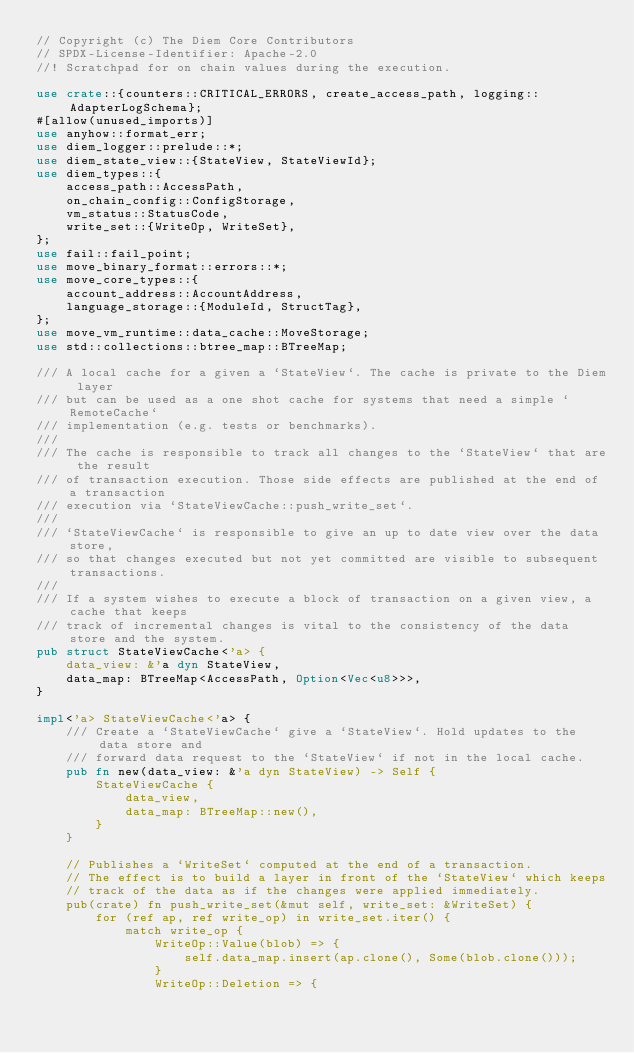<code> <loc_0><loc_0><loc_500><loc_500><_Rust_>// Copyright (c) The Diem Core Contributors
// SPDX-License-Identifier: Apache-2.0
//! Scratchpad for on chain values during the execution.

use crate::{counters::CRITICAL_ERRORS, create_access_path, logging::AdapterLogSchema};
#[allow(unused_imports)]
use anyhow::format_err;
use diem_logger::prelude::*;
use diem_state_view::{StateView, StateViewId};
use diem_types::{
    access_path::AccessPath,
    on_chain_config::ConfigStorage,
    vm_status::StatusCode,
    write_set::{WriteOp, WriteSet},
};
use fail::fail_point;
use move_binary_format::errors::*;
use move_core_types::{
    account_address::AccountAddress,
    language_storage::{ModuleId, StructTag},
};
use move_vm_runtime::data_cache::MoveStorage;
use std::collections::btree_map::BTreeMap;

/// A local cache for a given a `StateView`. The cache is private to the Diem layer
/// but can be used as a one shot cache for systems that need a simple `RemoteCache`
/// implementation (e.g. tests or benchmarks).
///
/// The cache is responsible to track all changes to the `StateView` that are the result
/// of transaction execution. Those side effects are published at the end of a transaction
/// execution via `StateViewCache::push_write_set`.
///
/// `StateViewCache` is responsible to give an up to date view over the data store,
/// so that changes executed but not yet committed are visible to subsequent transactions.
///
/// If a system wishes to execute a block of transaction on a given view, a cache that keeps
/// track of incremental changes is vital to the consistency of the data store and the system.
pub struct StateViewCache<'a> {
    data_view: &'a dyn StateView,
    data_map: BTreeMap<AccessPath, Option<Vec<u8>>>,
}

impl<'a> StateViewCache<'a> {
    /// Create a `StateViewCache` give a `StateView`. Hold updates to the data store and
    /// forward data request to the `StateView` if not in the local cache.
    pub fn new(data_view: &'a dyn StateView) -> Self {
        StateViewCache {
            data_view,
            data_map: BTreeMap::new(),
        }
    }

    // Publishes a `WriteSet` computed at the end of a transaction.
    // The effect is to build a layer in front of the `StateView` which keeps
    // track of the data as if the changes were applied immediately.
    pub(crate) fn push_write_set(&mut self, write_set: &WriteSet) {
        for (ref ap, ref write_op) in write_set.iter() {
            match write_op {
                WriteOp::Value(blob) => {
                    self.data_map.insert(ap.clone(), Some(blob.clone()));
                }
                WriteOp::Deletion => {</code> 